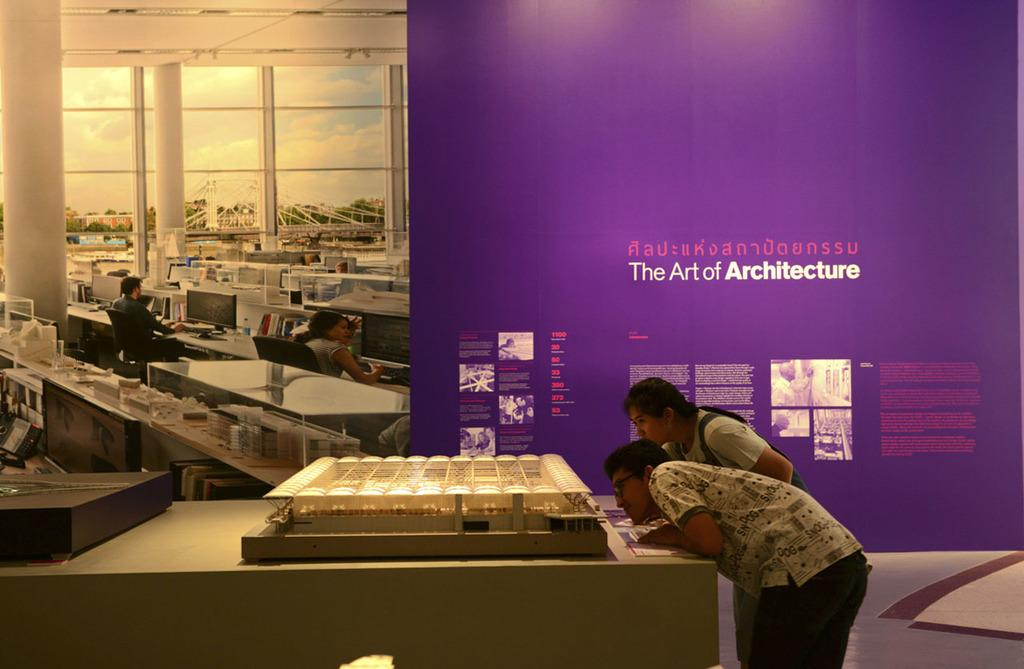Who is present in the image? There is a man and a woman in the image. What are the man and woman doing in the image? Both the man and woman are standing and observing a miniature. Can you describe the background of the image? There is a huge banner in the background of the image. What type of gun can be seen in the hands of the man in the image? There is no gun present in the image; the man and woman are observing a miniature. Can you describe the river visible in the image? There is no river present in the image. 